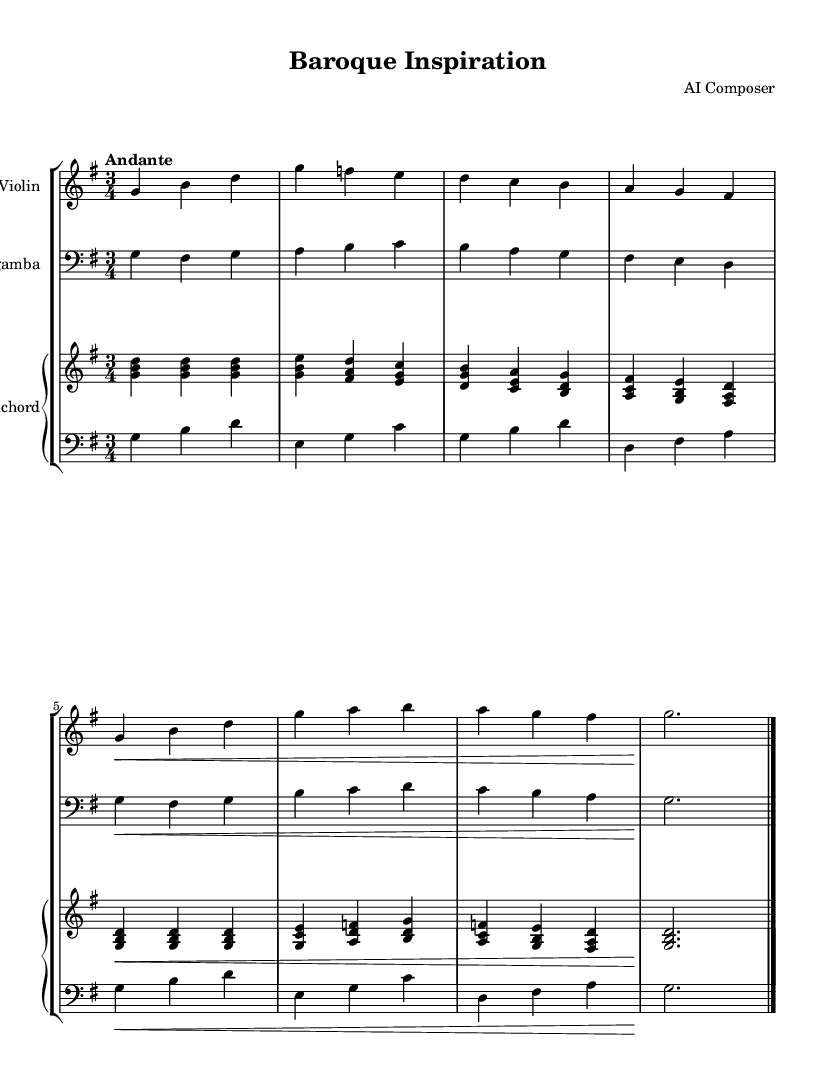What is the key signature of this music? The key signature shown in the music sheet indicates one sharp, placing it in the key of G major. This can be identified by looking at the key signature at the beginning of the score.
Answer: G major What is the time signature of this music? The time signature indicated in the sheet music is 3/4, which is shown at the beginning of the score. This means there are three beats in each measure.
Answer: 3/4 What is the tempo marking of this piece? The tempo marking appears as "Andante" in the score, which denotes a moderate pace of walking speed. It can be found near the beginning of the sheet music.
Answer: Andante How many measures are in the entire piece? By counting the vertical bars separating the measures, a total of eight measures can be identified in the piece. Each measure is marked with a vertical line to indicate bar lines.
Answer: 8 What is the dynamic marking for the violin part? The violin part features a crescendo marking (noted as \<) in the first line, indicating a gradual increase in volume. This is a common notation indicating the dynamics for the instrument.
Answer: Crescendo Is there a contrast in instrumentation? Yes, there are contrasting instruments as the piece includes violin, viola da gamba, and two staves for the harpsichord, which is typical for Baroque chamber music. By analyzing the score layout, we see different staves for each instrument.
Answer: Yes 